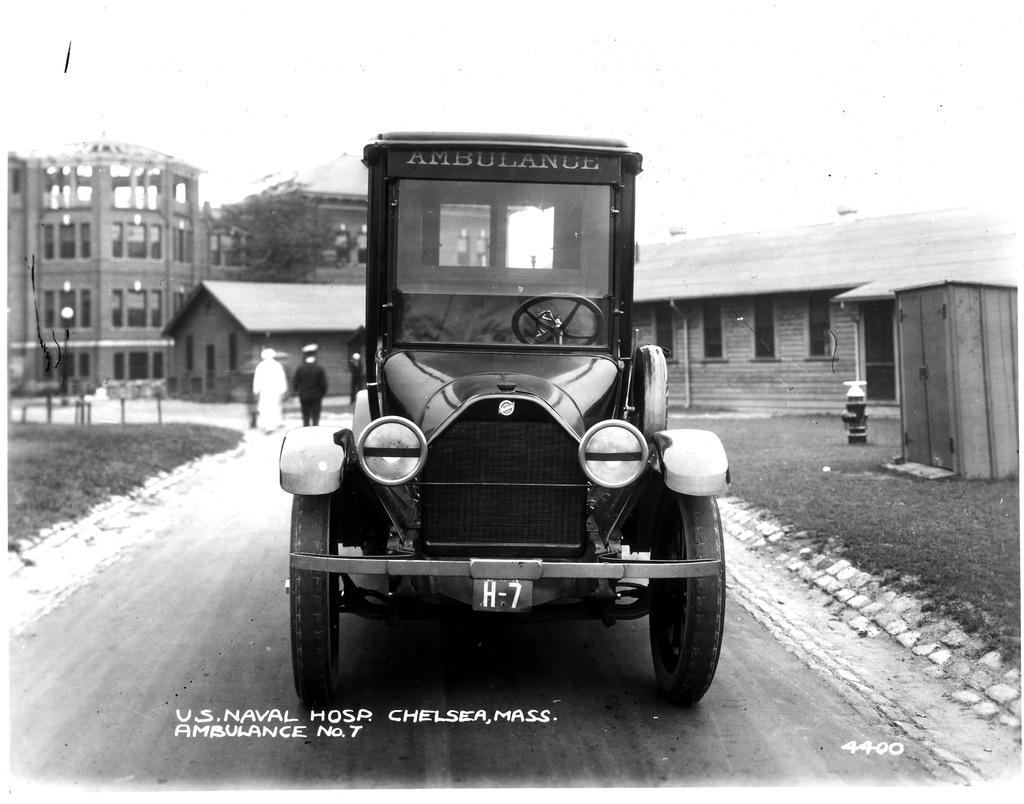What is the color scheme of the image? The image is black and white. What can be seen in the foreground of the image? There is a vehicle in the image. Who or what is located behind the vehicle? Two people are present behind the vehicle. What can be seen in the distance in the image? There are buildings in the background of the image. What is the price of the page depicted in the image? There is no page present in the image, and therefore no price can be determined. 